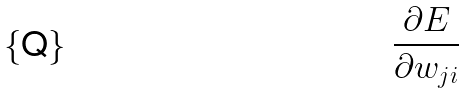Convert formula to latex. <formula><loc_0><loc_0><loc_500><loc_500>\frac { \partial E } { \partial w _ { j i } }</formula> 